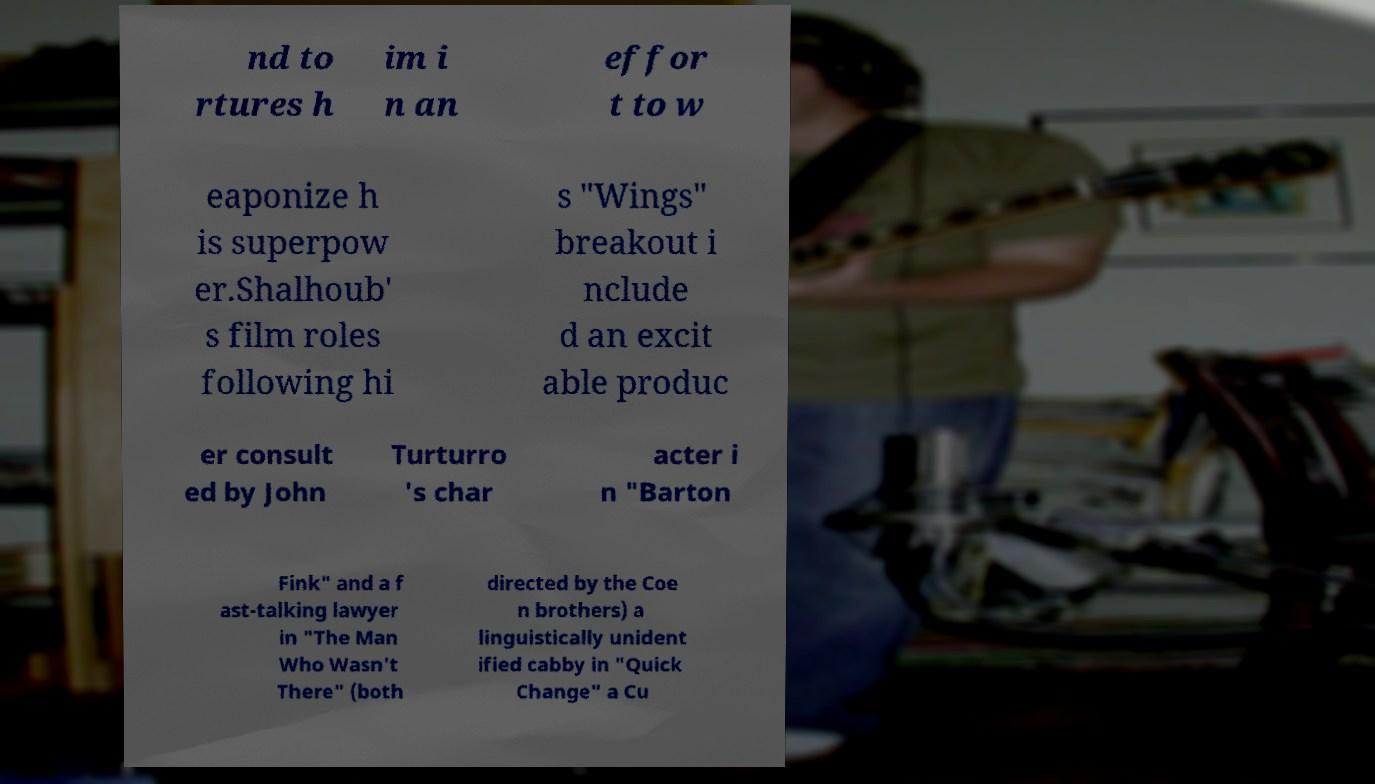There's text embedded in this image that I need extracted. Can you transcribe it verbatim? nd to rtures h im i n an effor t to w eaponize h is superpow er.Shalhoub' s film roles following hi s "Wings" breakout i nclude d an excit able produc er consult ed by John Turturro 's char acter i n "Barton Fink" and a f ast-talking lawyer in "The Man Who Wasn't There" (both directed by the Coe n brothers) a linguistically unident ified cabby in "Quick Change" a Cu 